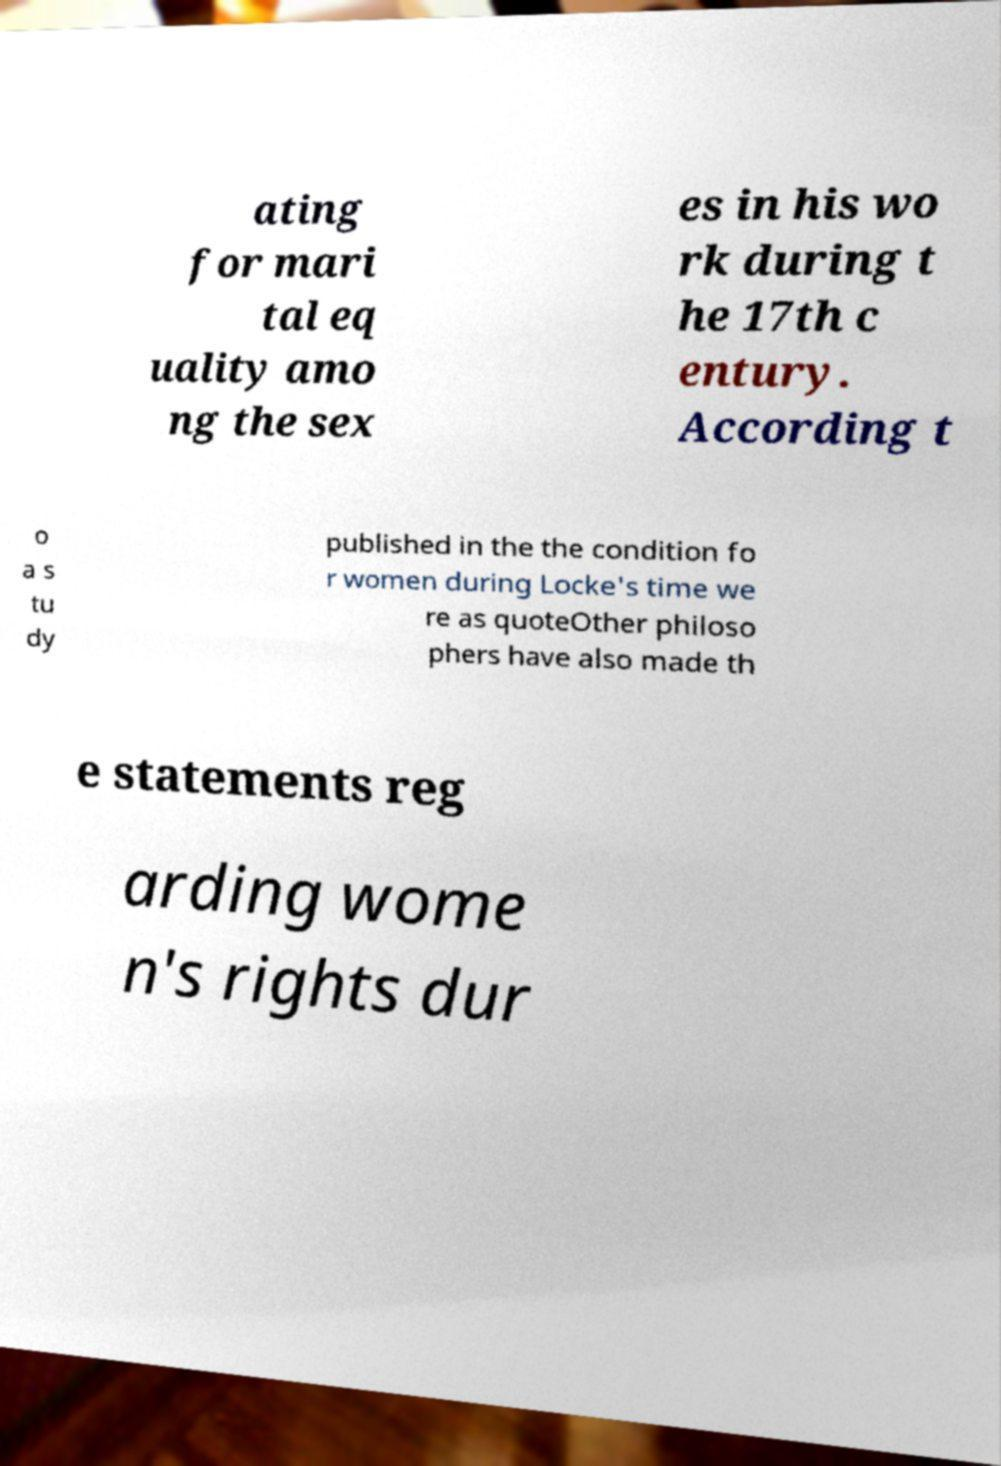What messages or text are displayed in this image? I need them in a readable, typed format. ating for mari tal eq uality amo ng the sex es in his wo rk during t he 17th c entury. According t o a s tu dy published in the the condition fo r women during Locke's time we re as quoteOther philoso phers have also made th e statements reg arding wome n's rights dur 